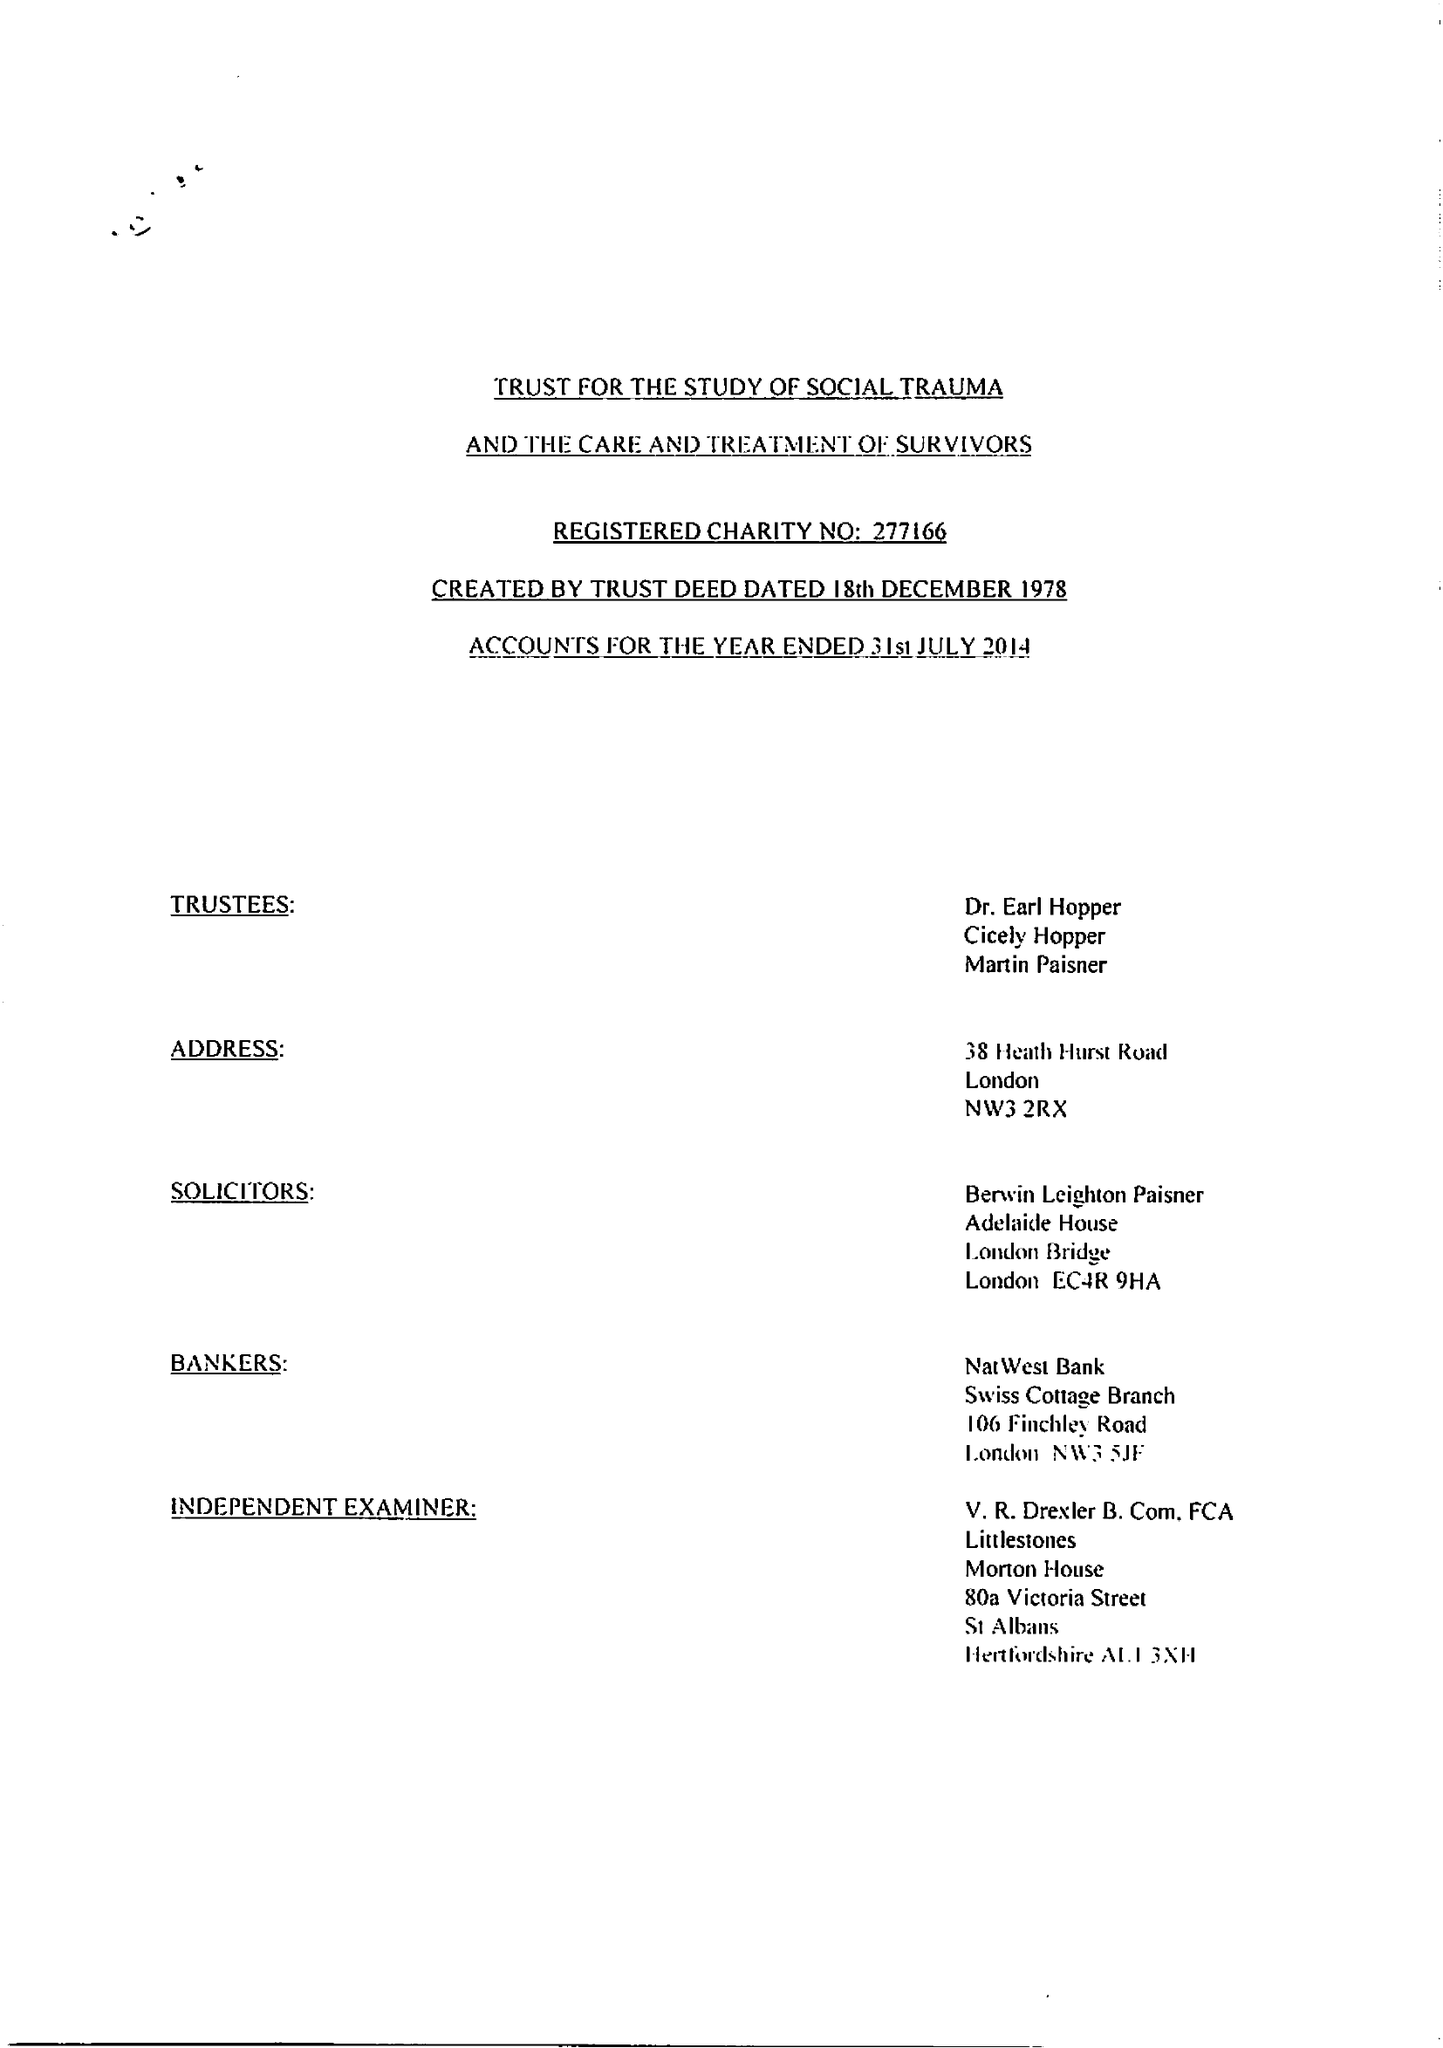What is the value for the spending_annually_in_british_pounds?
Answer the question using a single word or phrase. 21974.00 